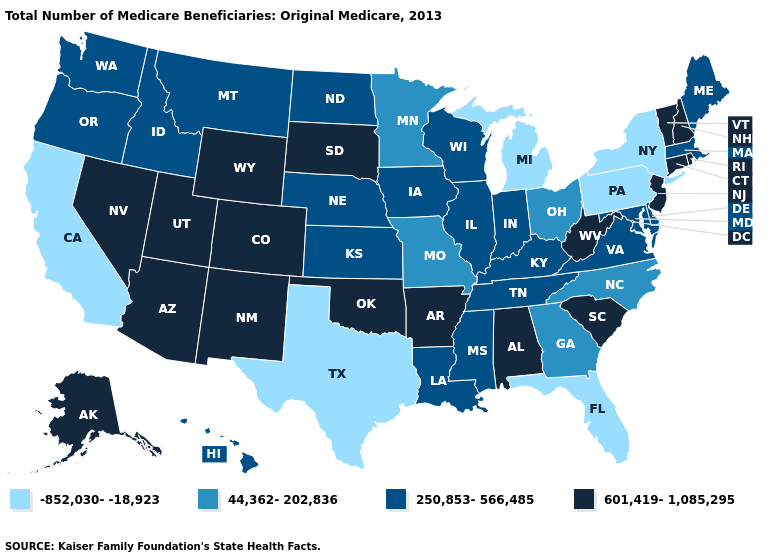Among the states that border New Mexico , does Arizona have the highest value?
Keep it brief. Yes. Among the states that border Washington , which have the highest value?
Write a very short answer. Idaho, Oregon. What is the value of Michigan?
Short answer required. -852,030--18,923. What is the lowest value in the South?
Quick response, please. -852,030--18,923. Is the legend a continuous bar?
Keep it brief. No. What is the value of Nevada?
Short answer required. 601,419-1,085,295. What is the value of Georgia?
Concise answer only. 44,362-202,836. Among the states that border Minnesota , does Iowa have the lowest value?
Short answer required. Yes. Does North Carolina have a lower value than Utah?
Short answer required. Yes. Name the states that have a value in the range -852,030--18,923?
Concise answer only. California, Florida, Michigan, New York, Pennsylvania, Texas. What is the lowest value in the USA?
Short answer required. -852,030--18,923. What is the value of North Carolina?
Write a very short answer. 44,362-202,836. Among the states that border New Jersey , which have the highest value?
Be succinct. Delaware. Does the map have missing data?
Quick response, please. No. Does South Dakota have the highest value in the USA?
Be succinct. Yes. 